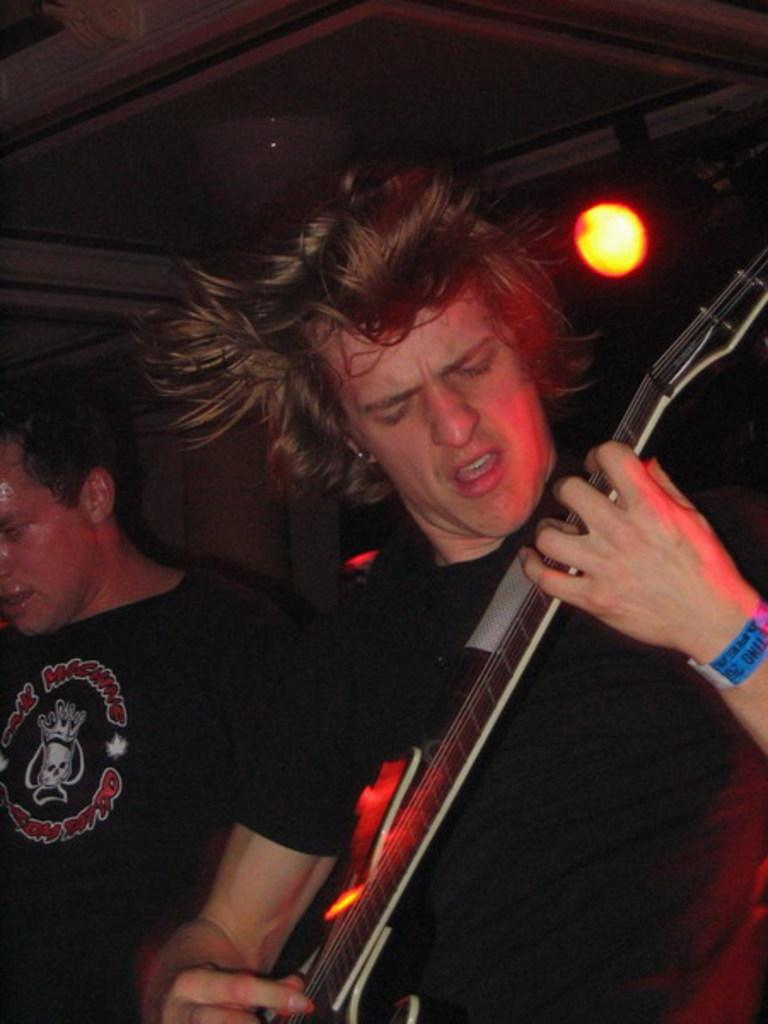What is the man in the image wearing? The man is wearing a black costume in the image. What is the man doing while wearing the costume? The man is playing a guitar in the image. Is there anyone else in the image with the guitar player? Yes, there is another man standing beside him in the image. What object can be seen in the image that is used for illumination? There is a yellow color flashlight in the image. How is the flashlight being used in the image? The flashlight is focused on the two men in the image. What type of furniture is being used by the tramp in the image? There is no tramp or furniture present in the image. 